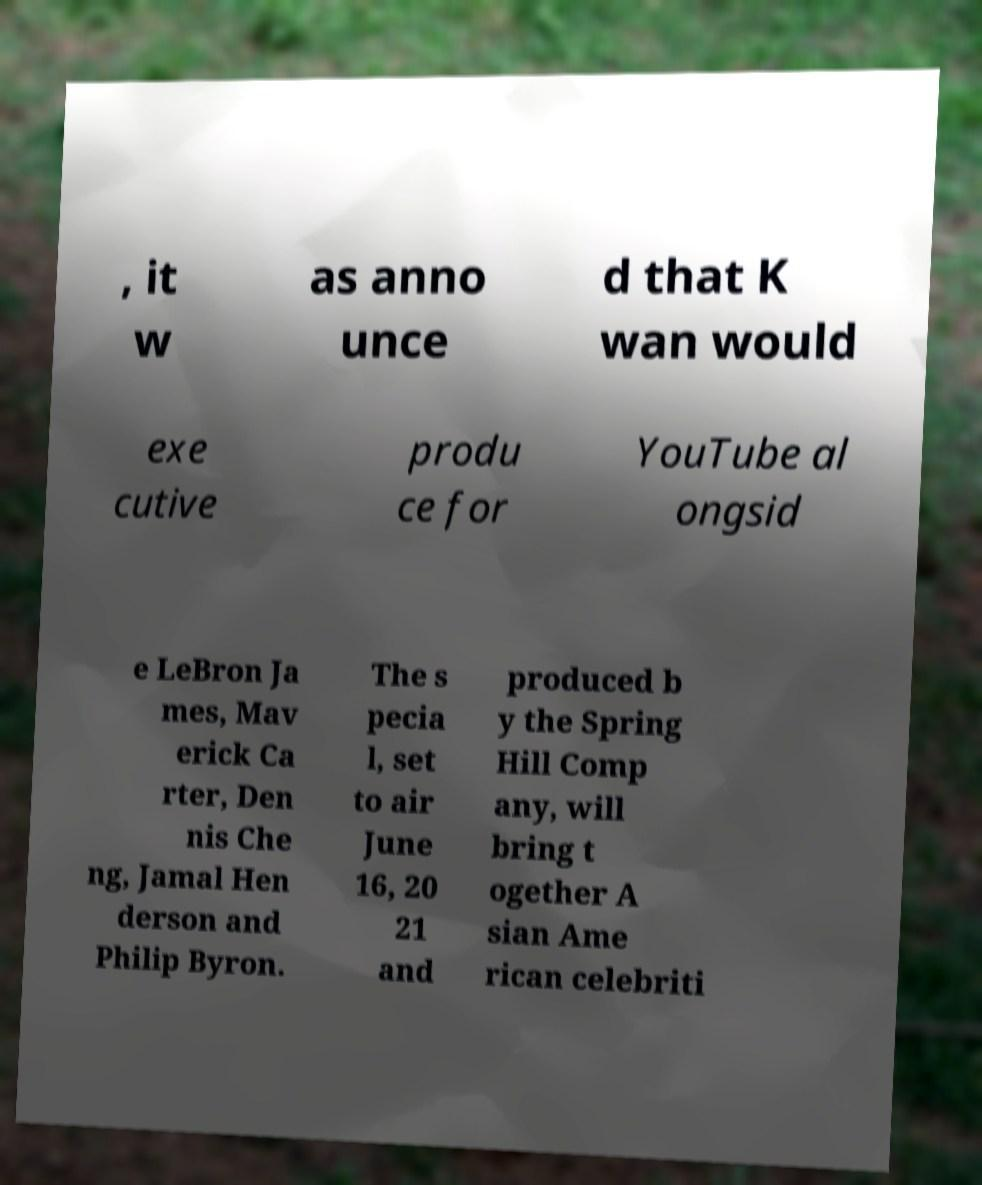Please identify and transcribe the text found in this image. , it w as anno unce d that K wan would exe cutive produ ce for YouTube al ongsid e LeBron Ja mes, Mav erick Ca rter, Den nis Che ng, Jamal Hen derson and Philip Byron. The s pecia l, set to air June 16, 20 21 and produced b y the Spring Hill Comp any, will bring t ogether A sian Ame rican celebriti 